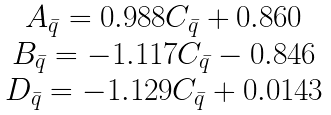<formula> <loc_0><loc_0><loc_500><loc_500>\begin{array} { c l l l c } A _ { \bar { q } } = 0 . 9 8 8 C _ { \bar { q } } + 0 . 8 6 0 \\ B _ { \bar { q } } = - 1 . 1 1 7 C _ { \bar { q } } - 0 . 8 4 6 \\ D _ { \bar { q } } = - 1 . 1 2 9 C _ { \bar { q } } + 0 . 0 1 4 3 \end{array}</formula> 